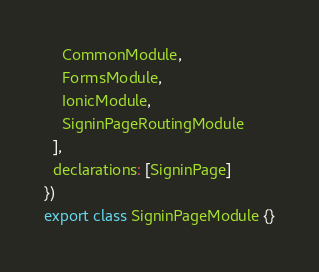<code> <loc_0><loc_0><loc_500><loc_500><_TypeScript_>    CommonModule,
    FormsModule,
    IonicModule,
    SigninPageRoutingModule
  ],
  declarations: [SigninPage]
})
export class SigninPageModule {}
</code> 